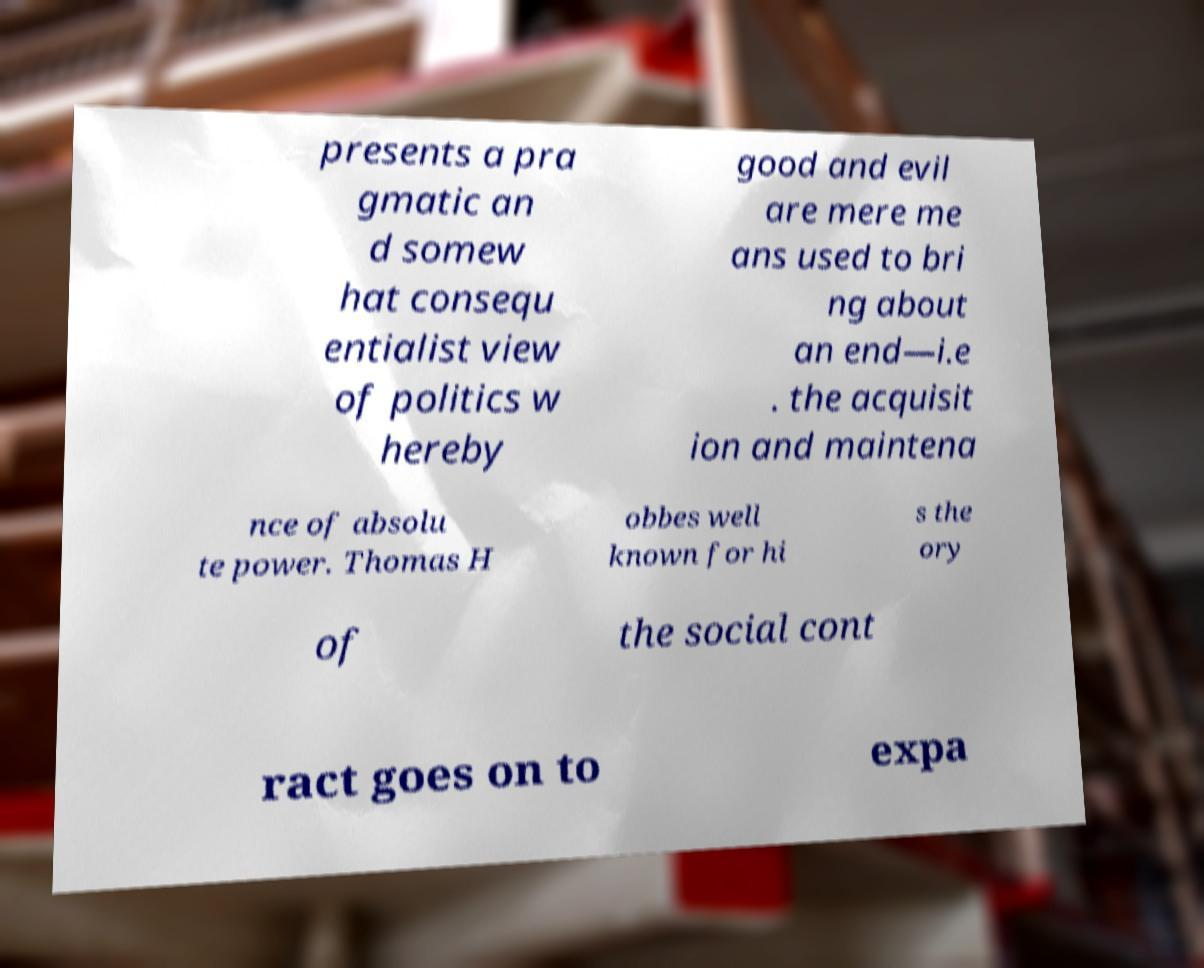There's text embedded in this image that I need extracted. Can you transcribe it verbatim? presents a pra gmatic an d somew hat consequ entialist view of politics w hereby good and evil are mere me ans used to bri ng about an end—i.e . the acquisit ion and maintena nce of absolu te power. Thomas H obbes well known for hi s the ory of the social cont ract goes on to expa 